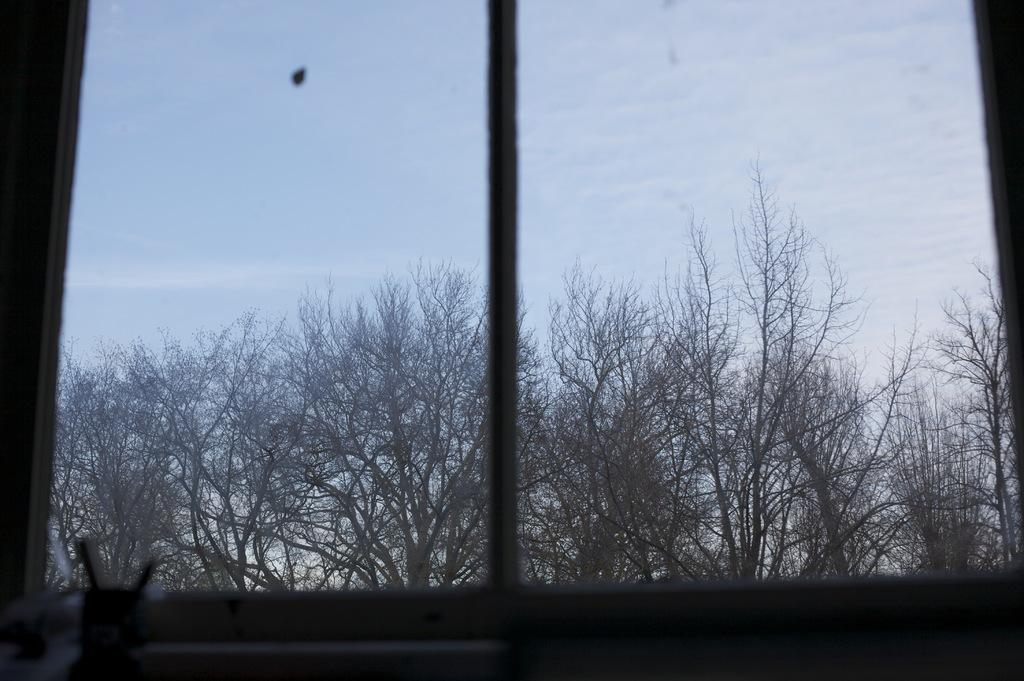What can be seen through the window in the image? Trees are visible through the window in the image. What is the color of the trees? The trees are brown in color. What else is visible in the image besides the trees? The sky is visible in the image. Is the pipe in the image making a quiet sound? There is no pipe present in the image, so it cannot be making any sound. 